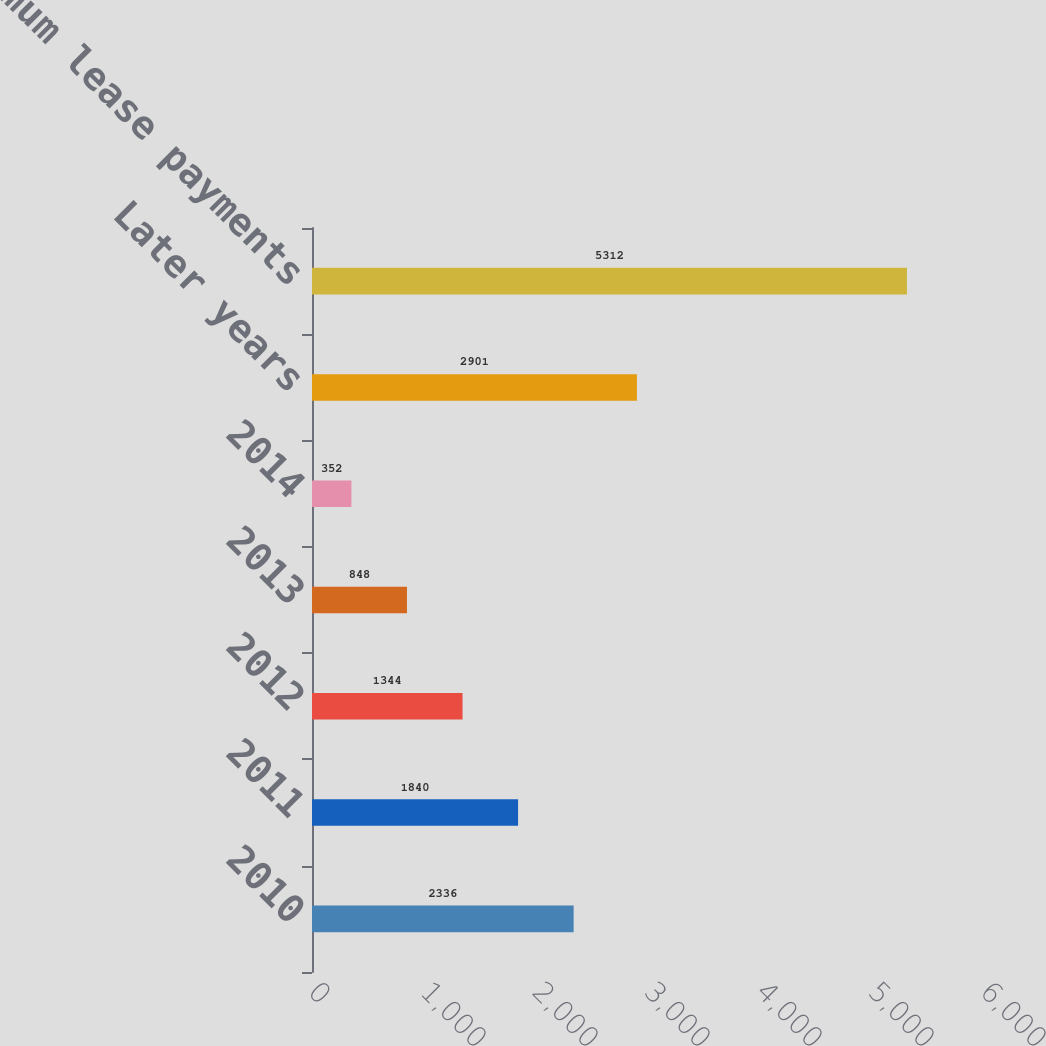Convert chart. <chart><loc_0><loc_0><loc_500><loc_500><bar_chart><fcel>2010<fcel>2011<fcel>2012<fcel>2013<fcel>2014<fcel>Later years<fcel>Total minimum lease payments<nl><fcel>2336<fcel>1840<fcel>1344<fcel>848<fcel>352<fcel>2901<fcel>5312<nl></chart> 